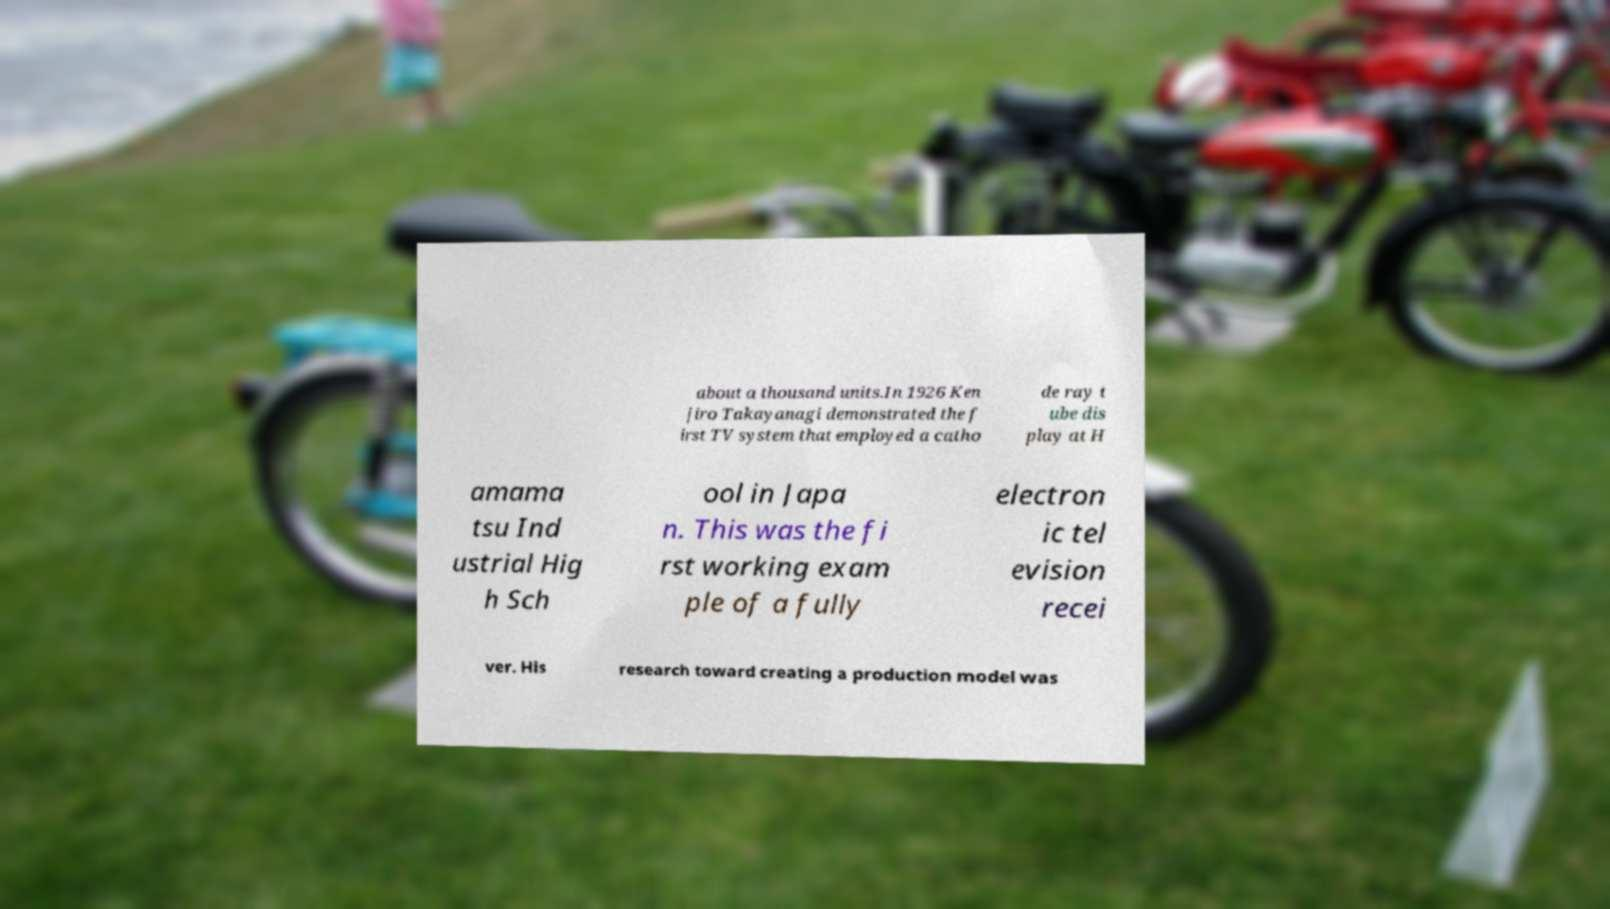Could you extract and type out the text from this image? about a thousand units.In 1926 Ken jiro Takayanagi demonstrated the f irst TV system that employed a catho de ray t ube dis play at H amama tsu Ind ustrial Hig h Sch ool in Japa n. This was the fi rst working exam ple of a fully electron ic tel evision recei ver. His research toward creating a production model was 